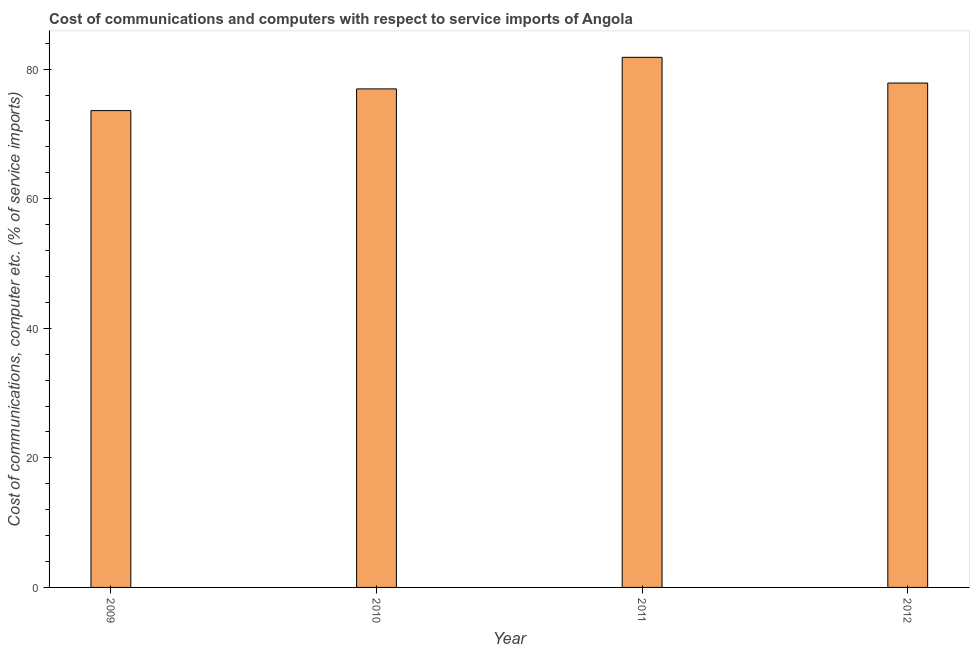Does the graph contain grids?
Your answer should be compact. No. What is the title of the graph?
Offer a terse response. Cost of communications and computers with respect to service imports of Angola. What is the label or title of the Y-axis?
Give a very brief answer. Cost of communications, computer etc. (% of service imports). What is the cost of communications and computer in 2010?
Keep it short and to the point. 76.94. Across all years, what is the maximum cost of communications and computer?
Give a very brief answer. 81.82. Across all years, what is the minimum cost of communications and computer?
Keep it short and to the point. 73.59. What is the sum of the cost of communications and computer?
Ensure brevity in your answer.  310.2. What is the difference between the cost of communications and computer in 2011 and 2012?
Your answer should be very brief. 3.97. What is the average cost of communications and computer per year?
Give a very brief answer. 77.55. What is the median cost of communications and computer?
Your response must be concise. 77.39. Do a majority of the years between 2009 and 2012 (inclusive) have cost of communications and computer greater than 60 %?
Provide a short and direct response. Yes. What is the ratio of the cost of communications and computer in 2009 to that in 2012?
Your answer should be compact. 0.94. Is the difference between the cost of communications and computer in 2011 and 2012 greater than the difference between any two years?
Offer a very short reply. No. What is the difference between the highest and the second highest cost of communications and computer?
Your answer should be very brief. 3.97. Is the sum of the cost of communications and computer in 2010 and 2011 greater than the maximum cost of communications and computer across all years?
Ensure brevity in your answer.  Yes. What is the difference between the highest and the lowest cost of communications and computer?
Keep it short and to the point. 8.22. How many bars are there?
Make the answer very short. 4. Are all the bars in the graph horizontal?
Your answer should be compact. No. How many years are there in the graph?
Give a very brief answer. 4. What is the Cost of communications, computer etc. (% of service imports) of 2009?
Make the answer very short. 73.59. What is the Cost of communications, computer etc. (% of service imports) of 2010?
Make the answer very short. 76.94. What is the Cost of communications, computer etc. (% of service imports) of 2011?
Offer a very short reply. 81.82. What is the Cost of communications, computer etc. (% of service imports) in 2012?
Provide a short and direct response. 77.85. What is the difference between the Cost of communications, computer etc. (% of service imports) in 2009 and 2010?
Your answer should be very brief. -3.35. What is the difference between the Cost of communications, computer etc. (% of service imports) in 2009 and 2011?
Keep it short and to the point. -8.22. What is the difference between the Cost of communications, computer etc. (% of service imports) in 2009 and 2012?
Provide a succinct answer. -4.25. What is the difference between the Cost of communications, computer etc. (% of service imports) in 2010 and 2011?
Your response must be concise. -4.87. What is the difference between the Cost of communications, computer etc. (% of service imports) in 2010 and 2012?
Keep it short and to the point. -0.9. What is the difference between the Cost of communications, computer etc. (% of service imports) in 2011 and 2012?
Keep it short and to the point. 3.97. What is the ratio of the Cost of communications, computer etc. (% of service imports) in 2009 to that in 2010?
Your response must be concise. 0.96. What is the ratio of the Cost of communications, computer etc. (% of service imports) in 2009 to that in 2011?
Give a very brief answer. 0.9. What is the ratio of the Cost of communications, computer etc. (% of service imports) in 2009 to that in 2012?
Keep it short and to the point. 0.94. What is the ratio of the Cost of communications, computer etc. (% of service imports) in 2011 to that in 2012?
Your response must be concise. 1.05. 